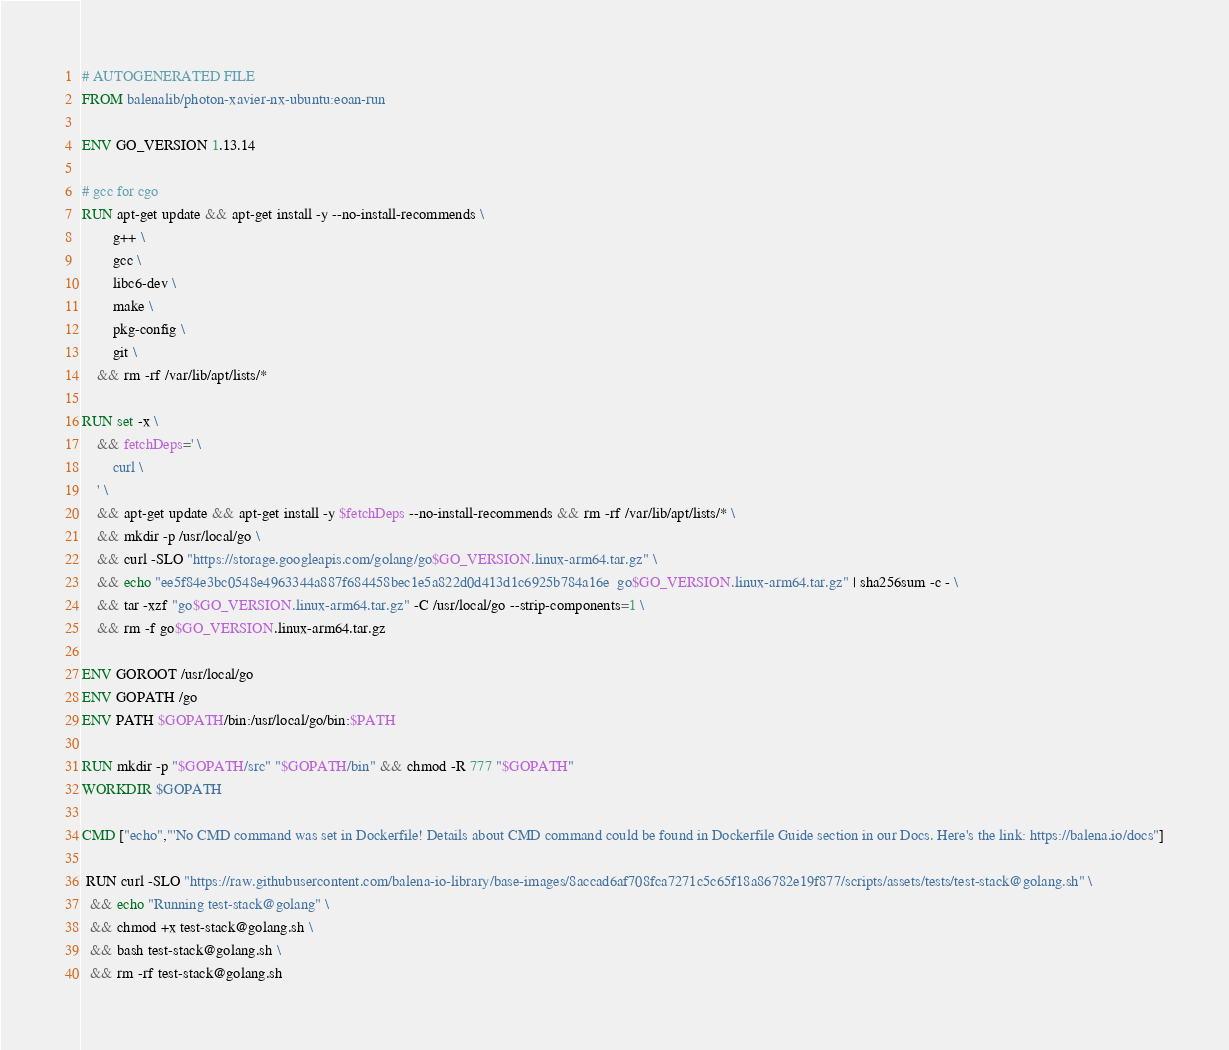<code> <loc_0><loc_0><loc_500><loc_500><_Dockerfile_># AUTOGENERATED FILE
FROM balenalib/photon-xavier-nx-ubuntu:eoan-run

ENV GO_VERSION 1.13.14

# gcc for cgo
RUN apt-get update && apt-get install -y --no-install-recommends \
		g++ \
		gcc \
		libc6-dev \
		make \
		pkg-config \
		git \
	&& rm -rf /var/lib/apt/lists/*

RUN set -x \
	&& fetchDeps=' \
		curl \
	' \
	&& apt-get update && apt-get install -y $fetchDeps --no-install-recommends && rm -rf /var/lib/apt/lists/* \
	&& mkdir -p /usr/local/go \
	&& curl -SLO "https://storage.googleapis.com/golang/go$GO_VERSION.linux-arm64.tar.gz" \
	&& echo "ee5f84e3bc0548e4963344a887f684458bec1e5a822d0d413d1c6925b784a16e  go$GO_VERSION.linux-arm64.tar.gz" | sha256sum -c - \
	&& tar -xzf "go$GO_VERSION.linux-arm64.tar.gz" -C /usr/local/go --strip-components=1 \
	&& rm -f go$GO_VERSION.linux-arm64.tar.gz

ENV GOROOT /usr/local/go
ENV GOPATH /go
ENV PATH $GOPATH/bin:/usr/local/go/bin:$PATH

RUN mkdir -p "$GOPATH/src" "$GOPATH/bin" && chmod -R 777 "$GOPATH"
WORKDIR $GOPATH

CMD ["echo","'No CMD command was set in Dockerfile! Details about CMD command could be found in Dockerfile Guide section in our Docs. Here's the link: https://balena.io/docs"]

 RUN curl -SLO "https://raw.githubusercontent.com/balena-io-library/base-images/8accad6af708fca7271c5c65f18a86782e19f877/scripts/assets/tests/test-stack@golang.sh" \
  && echo "Running test-stack@golang" \
  && chmod +x test-stack@golang.sh \
  && bash test-stack@golang.sh \
  && rm -rf test-stack@golang.sh 
</code> 